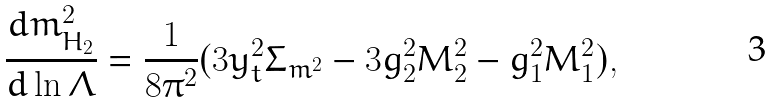Convert formula to latex. <formula><loc_0><loc_0><loc_500><loc_500>\frac { d m _ { H _ { 2 } } ^ { 2 } } { d \ln \Lambda } = \frac { 1 } { 8 \pi ^ { 2 } } ( 3 y _ { t } ^ { 2 } \Sigma _ { m ^ { 2 } } - 3 g _ { 2 } ^ { 2 } M _ { 2 } ^ { 2 } - g _ { 1 } ^ { 2 } M _ { 1 } ^ { 2 } ) ,</formula> 